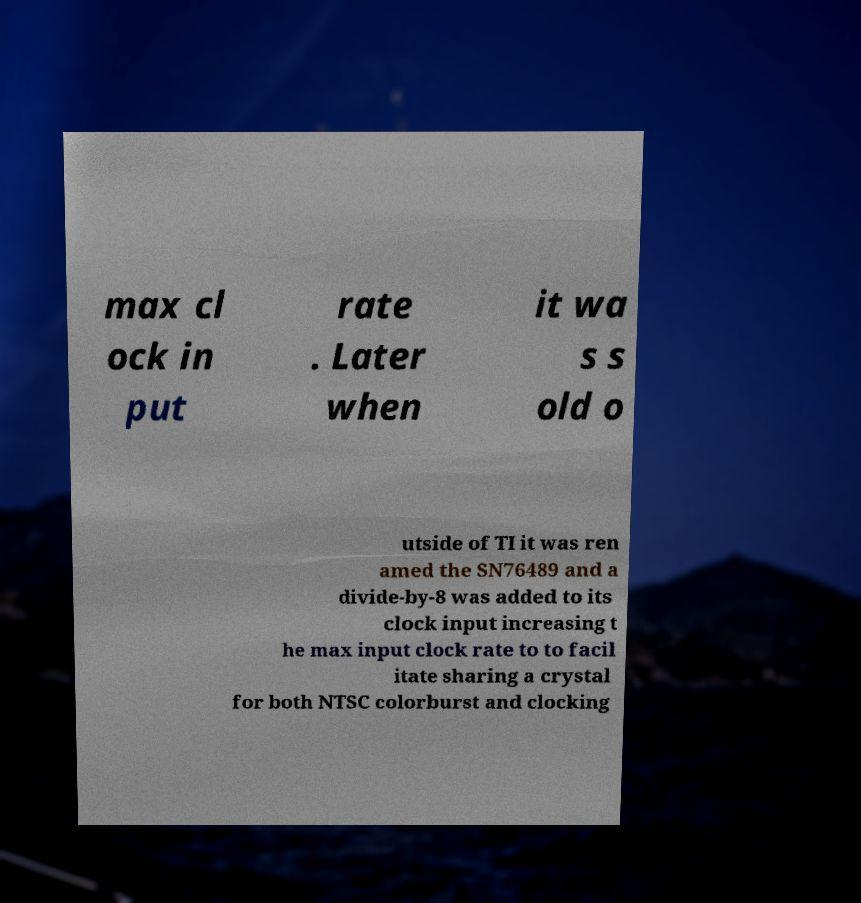I need the written content from this picture converted into text. Can you do that? max cl ock in put rate . Later when it wa s s old o utside of TI it was ren amed the SN76489 and a divide-by-8 was added to its clock input increasing t he max input clock rate to to facil itate sharing a crystal for both NTSC colorburst and clocking 